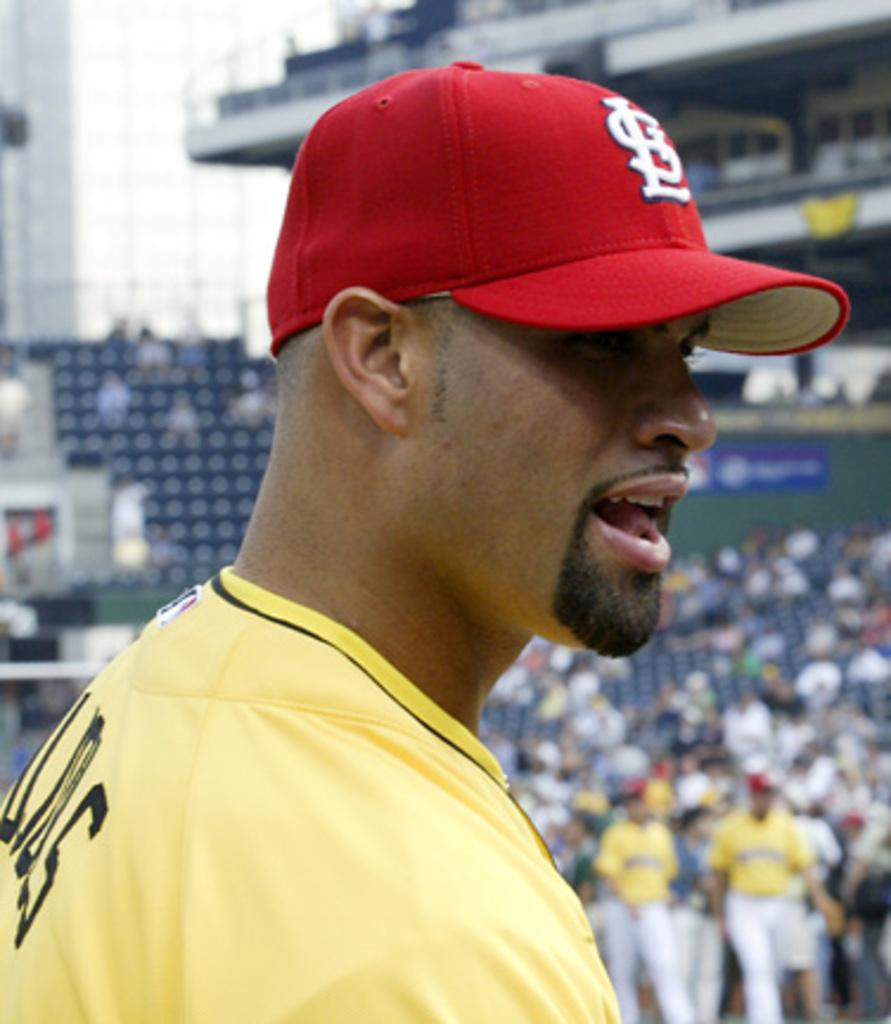<image>
Offer a succinct explanation of the picture presented. the letters SL are on the hat of the person 